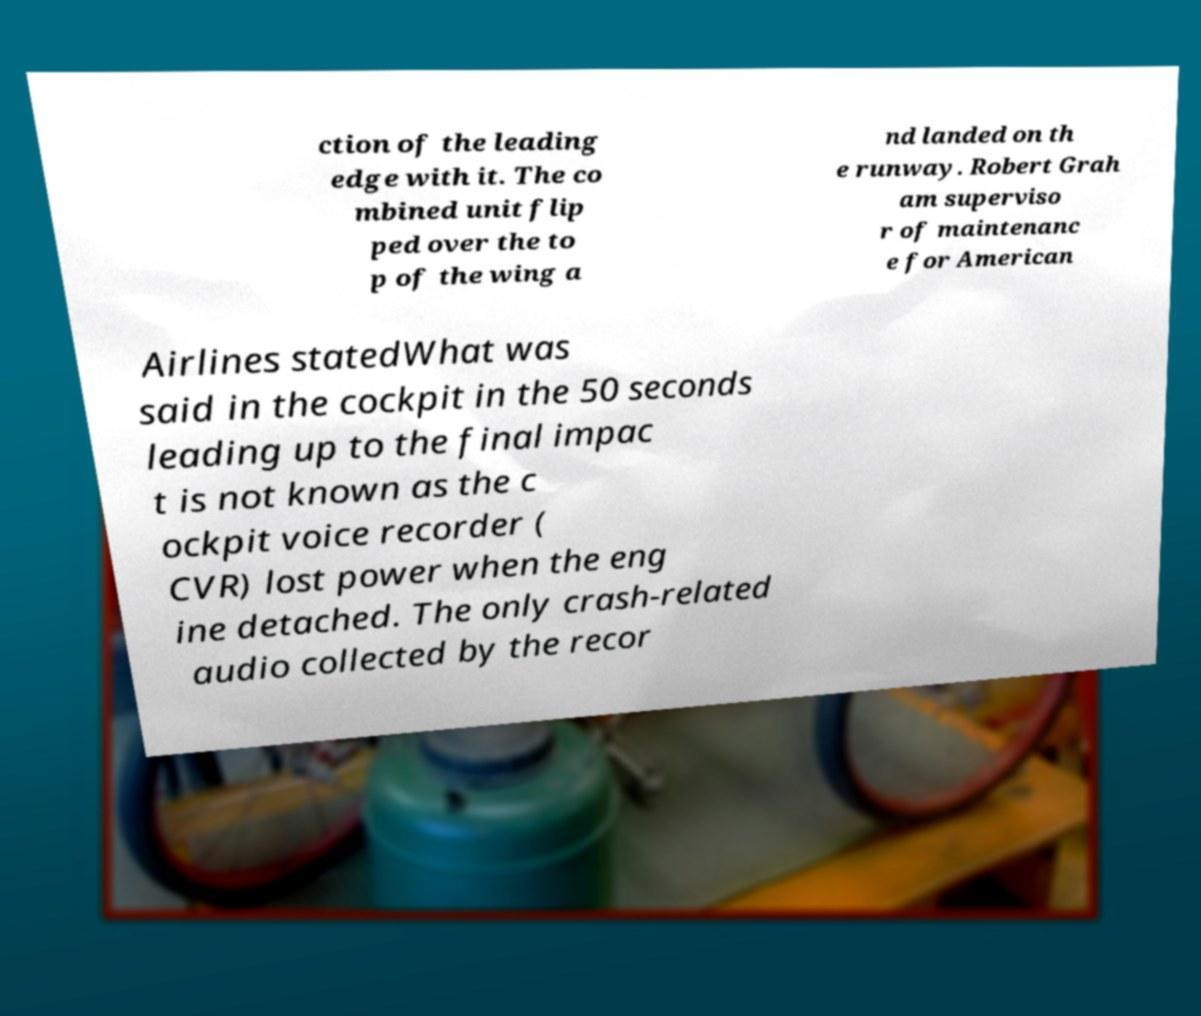Please identify and transcribe the text found in this image. ction of the leading edge with it. The co mbined unit flip ped over the to p of the wing a nd landed on th e runway. Robert Grah am superviso r of maintenanc e for American Airlines statedWhat was said in the cockpit in the 50 seconds leading up to the final impac t is not known as the c ockpit voice recorder ( CVR) lost power when the eng ine detached. The only crash-related audio collected by the recor 